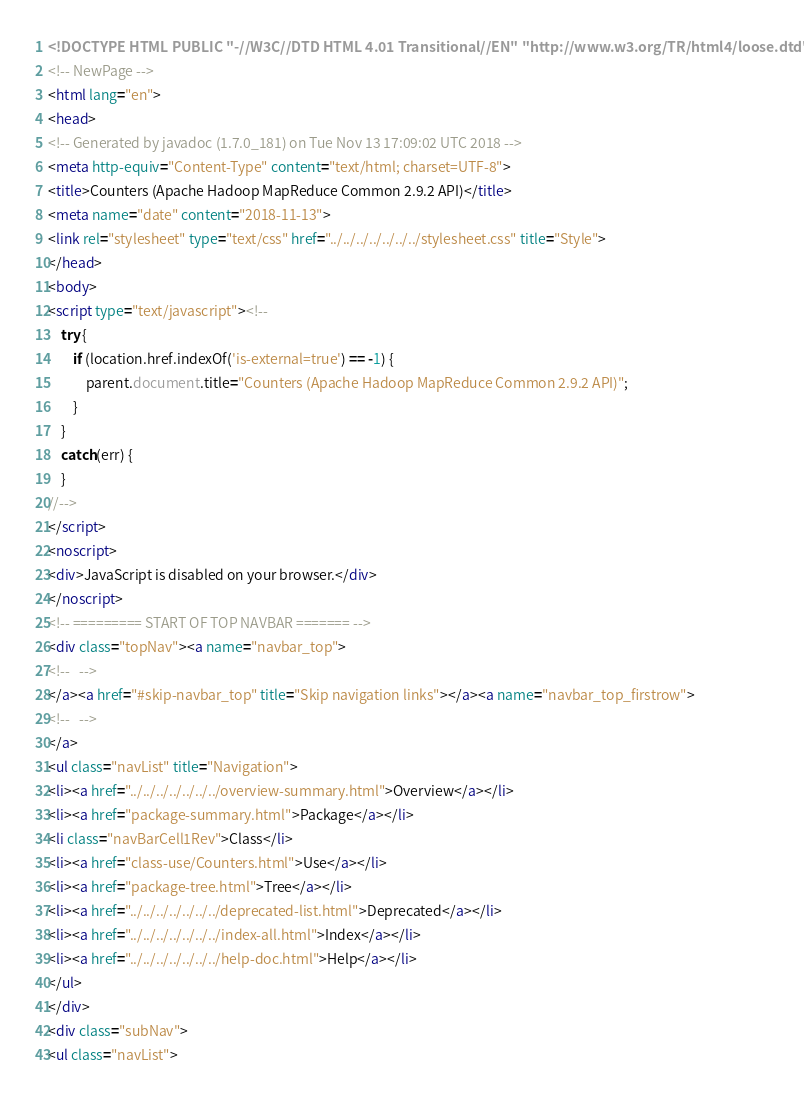<code> <loc_0><loc_0><loc_500><loc_500><_HTML_><!DOCTYPE HTML PUBLIC "-//W3C//DTD HTML 4.01 Transitional//EN" "http://www.w3.org/TR/html4/loose.dtd">
<!-- NewPage -->
<html lang="en">
<head>
<!-- Generated by javadoc (1.7.0_181) on Tue Nov 13 17:09:02 UTC 2018 -->
<meta http-equiv="Content-Type" content="text/html; charset=UTF-8">
<title>Counters (Apache Hadoop MapReduce Common 2.9.2 API)</title>
<meta name="date" content="2018-11-13">
<link rel="stylesheet" type="text/css" href="../../../../../../../stylesheet.css" title="Style">
</head>
<body>
<script type="text/javascript"><!--
    try {
        if (location.href.indexOf('is-external=true') == -1) {
            parent.document.title="Counters (Apache Hadoop MapReduce Common 2.9.2 API)";
        }
    }
    catch(err) {
    }
//-->
</script>
<noscript>
<div>JavaScript is disabled on your browser.</div>
</noscript>
<!-- ========= START OF TOP NAVBAR ======= -->
<div class="topNav"><a name="navbar_top">
<!--   -->
</a><a href="#skip-navbar_top" title="Skip navigation links"></a><a name="navbar_top_firstrow">
<!--   -->
</a>
<ul class="navList" title="Navigation">
<li><a href="../../../../../../../overview-summary.html">Overview</a></li>
<li><a href="package-summary.html">Package</a></li>
<li class="navBarCell1Rev">Class</li>
<li><a href="class-use/Counters.html">Use</a></li>
<li><a href="package-tree.html">Tree</a></li>
<li><a href="../../../../../../../deprecated-list.html">Deprecated</a></li>
<li><a href="../../../../../../../index-all.html">Index</a></li>
<li><a href="../../../../../../../help-doc.html">Help</a></li>
</ul>
</div>
<div class="subNav">
<ul class="navList"></code> 